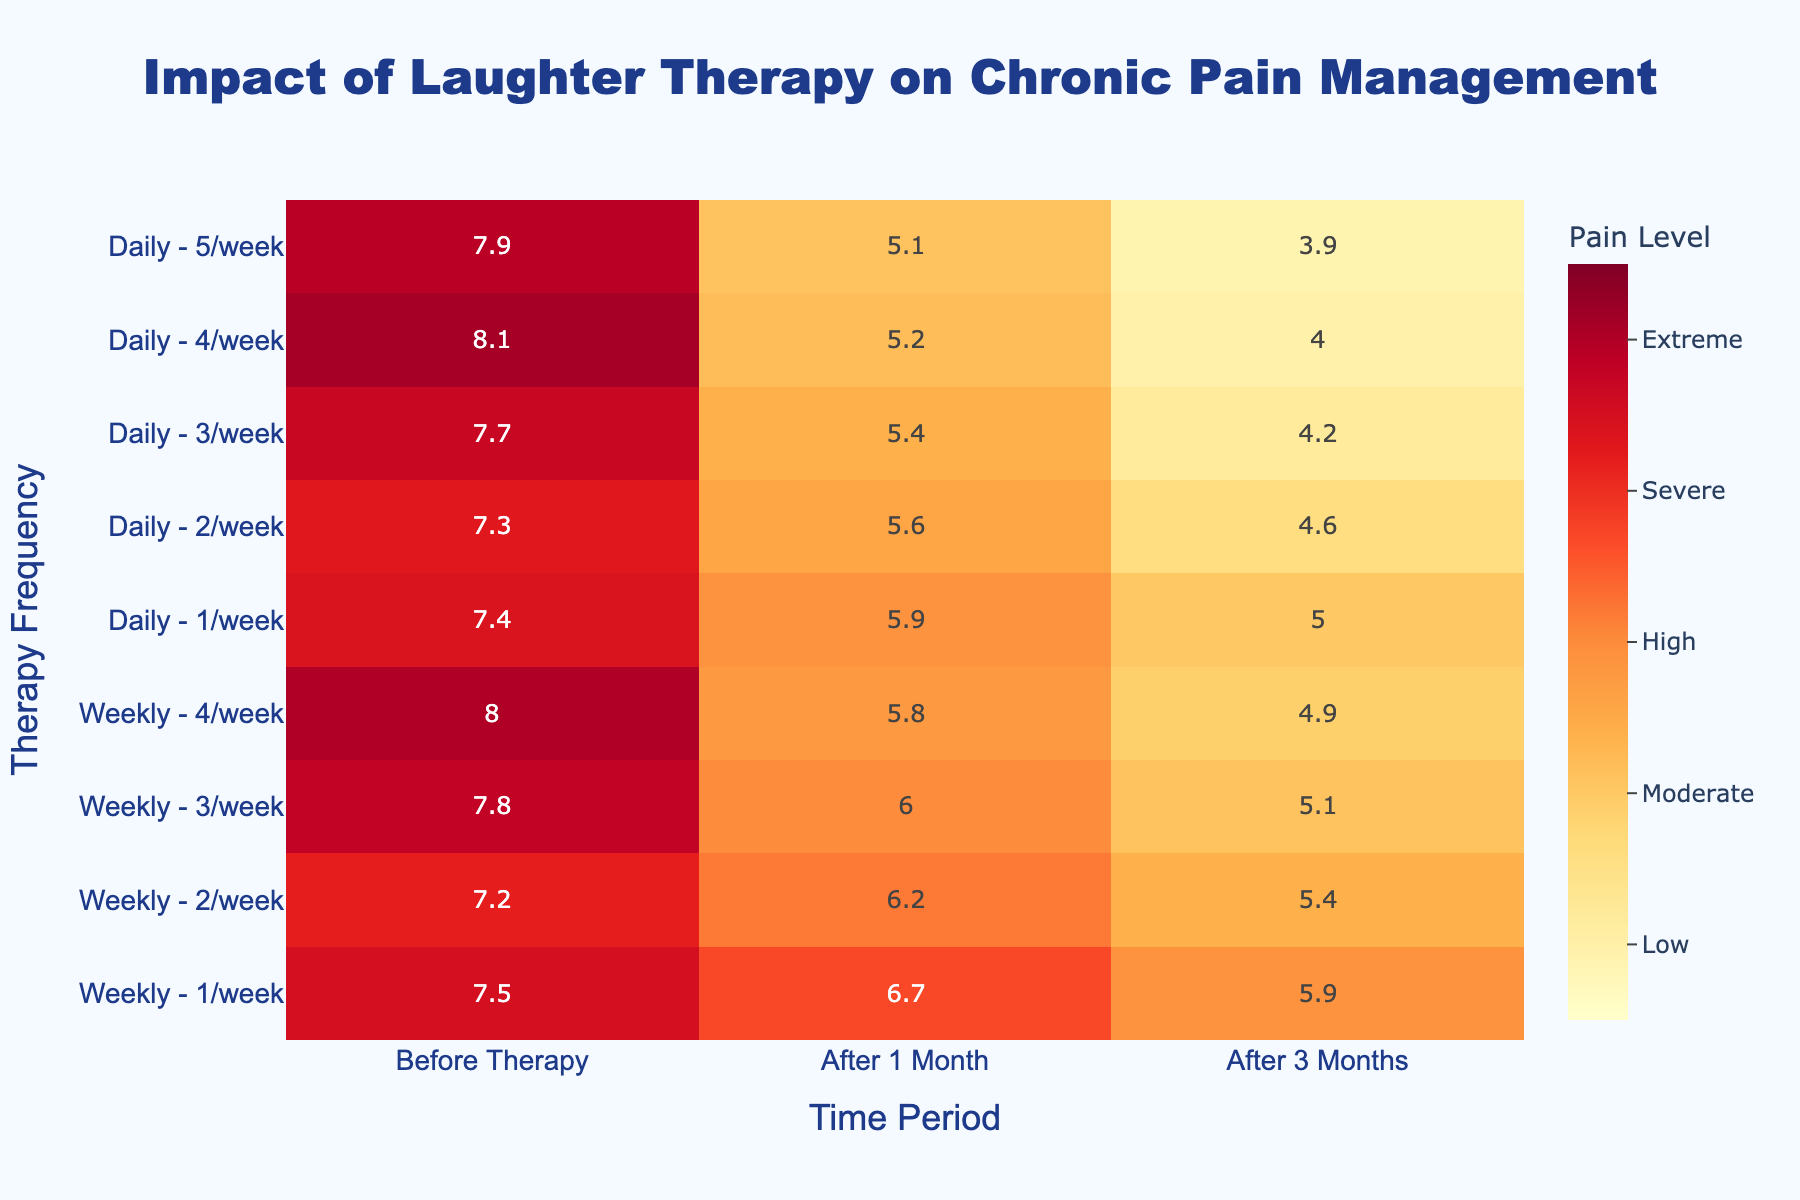What's the title of the heatmap? The title is located at the top of the figure. It reads "Impact of Laughter Therapy on Chronic Pain Management".
Answer: Impact of Laughter Therapy on Chronic Pain Management How many different frequencies of laughter therapy are represented? There are two different frequencies indicated on the y-axis, which are 'Weekly' and 'Daily'.
Answer: 2 What is the average pain level before therapy for 'Weekly' frequency with 1 session per week? Look at the intersection of 'Weekly - 1/week' row and 'Before Therapy' column in the heatmap. The value is given as 7.5.
Answer: 7.5 Which group showed the greatest improvement after 1 month of laughter therapy on a daily basis? To find the group with the greatest improvement, we need to compare the difference between 'Before Therapy' and 'After 1 Month' values for daily frequencies. The greatest drop in value is for 'Daily - 2/week' where it goes from 7.3 to 5.6 (a difference of 1.7).
Answer: Daily - 2/week Does the number of laughter therapy sessions per week correlate with the improvement in pain levels after 3 months? Look at the pain levels after 3 months for both 'Weekly' and 'Daily' frequencies. As the number of sessions increases, the pain levels generally decrease, indicating a positive correlation.
Answer: Yes By how much did the average pain level decrease from before therapy to after 3 months for 'Daily' frequency with 3 sessions per week? Check the values for 'Daily - 3/week'. The average pain level before therapy is 7.7, and after 3 months, it is 4.2. The decrease is 7.7 - 4.2 = 3.5.
Answer: 3.5 Which frequency and number of sessions per week showed the lowest pain level after 3 months? Look at the column for 'After 3 Months' and identify the smallest value. The lowest pain level is 3.9 for 'Daily - 5/week'.
Answer: Daily - 5/week What is the difference in pain levels after 1 month between 'Weekly - 3/week' and 'Daily - 3/week'? The pain level for 'Weekly - 3/week' after 1 month is 6.0, and for 'Daily - 3/week', it is 5.4. The difference is 6.0 - 5.4 = 0.6.
Answer: 0.6 Which time period shows the least amount of improvement across all sessions and frequencies? Compare the values across 'Before Therapy', 'After 1 Month', and 'After 3 Months'. Overall, the improvements are smaller after 1 month compared to 3 months, so 1 month shows the least amount of improvement.
Answer: After 1 Month 